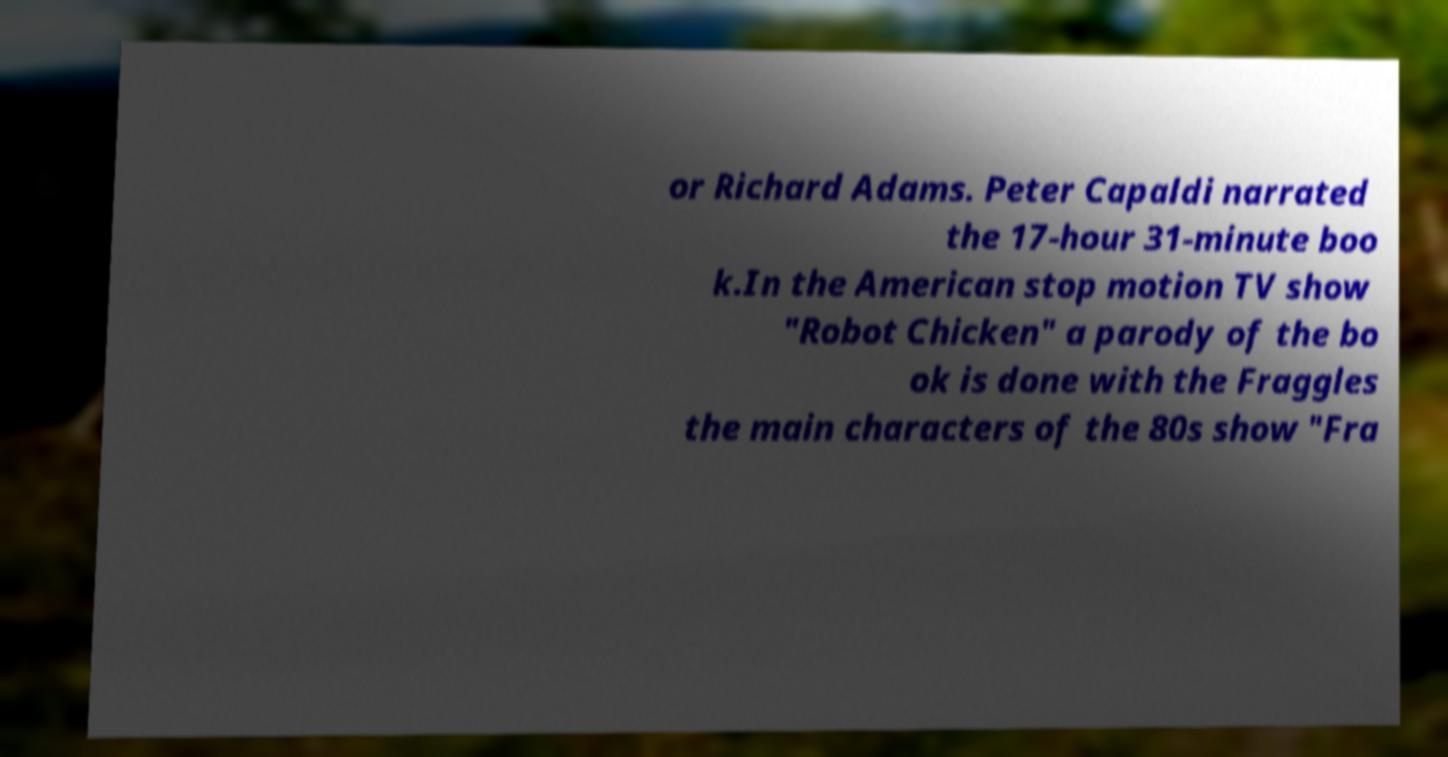For documentation purposes, I need the text within this image transcribed. Could you provide that? or Richard Adams. Peter Capaldi narrated the 17-hour 31-minute boo k.In the American stop motion TV show "Robot Chicken" a parody of the bo ok is done with the Fraggles the main characters of the 80s show "Fra 